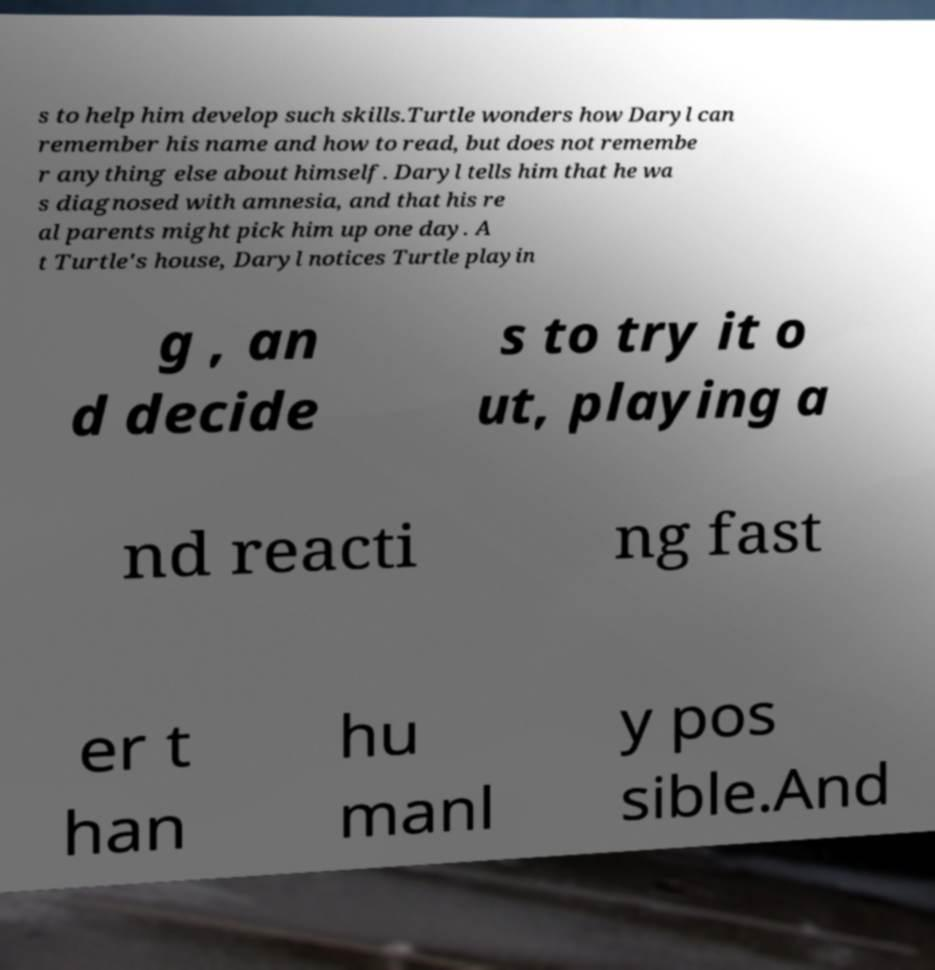Could you assist in decoding the text presented in this image and type it out clearly? s to help him develop such skills.Turtle wonders how Daryl can remember his name and how to read, but does not remembe r anything else about himself. Daryl tells him that he wa s diagnosed with amnesia, and that his re al parents might pick him up one day. A t Turtle's house, Daryl notices Turtle playin g , an d decide s to try it o ut, playing a nd reacti ng fast er t han hu manl y pos sible.And 